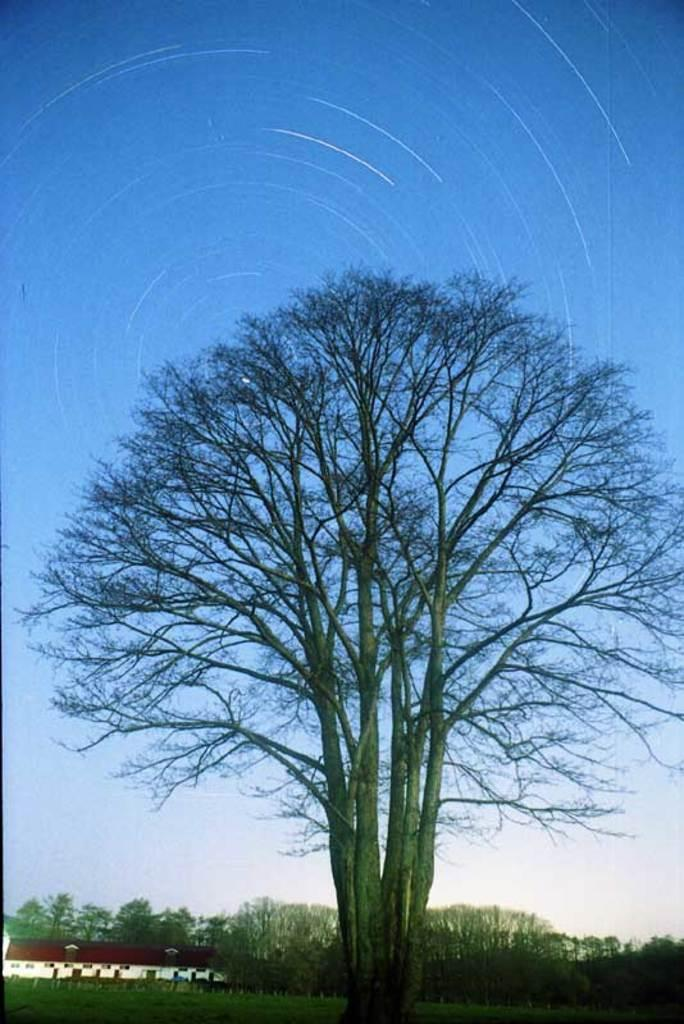What type of natural vegetation can be seen in the image? There are trees in the image. Where is the shelter house located in the image? The shelter house is in the bottom left of the image. What can be seen in the background of the image? There is a sky visible in the background of the image. Are there any lizards visible in the image? There are no lizards present in the image. What type of room is shown in the image? The image does not depict a room; it features trees and a shelter house. 